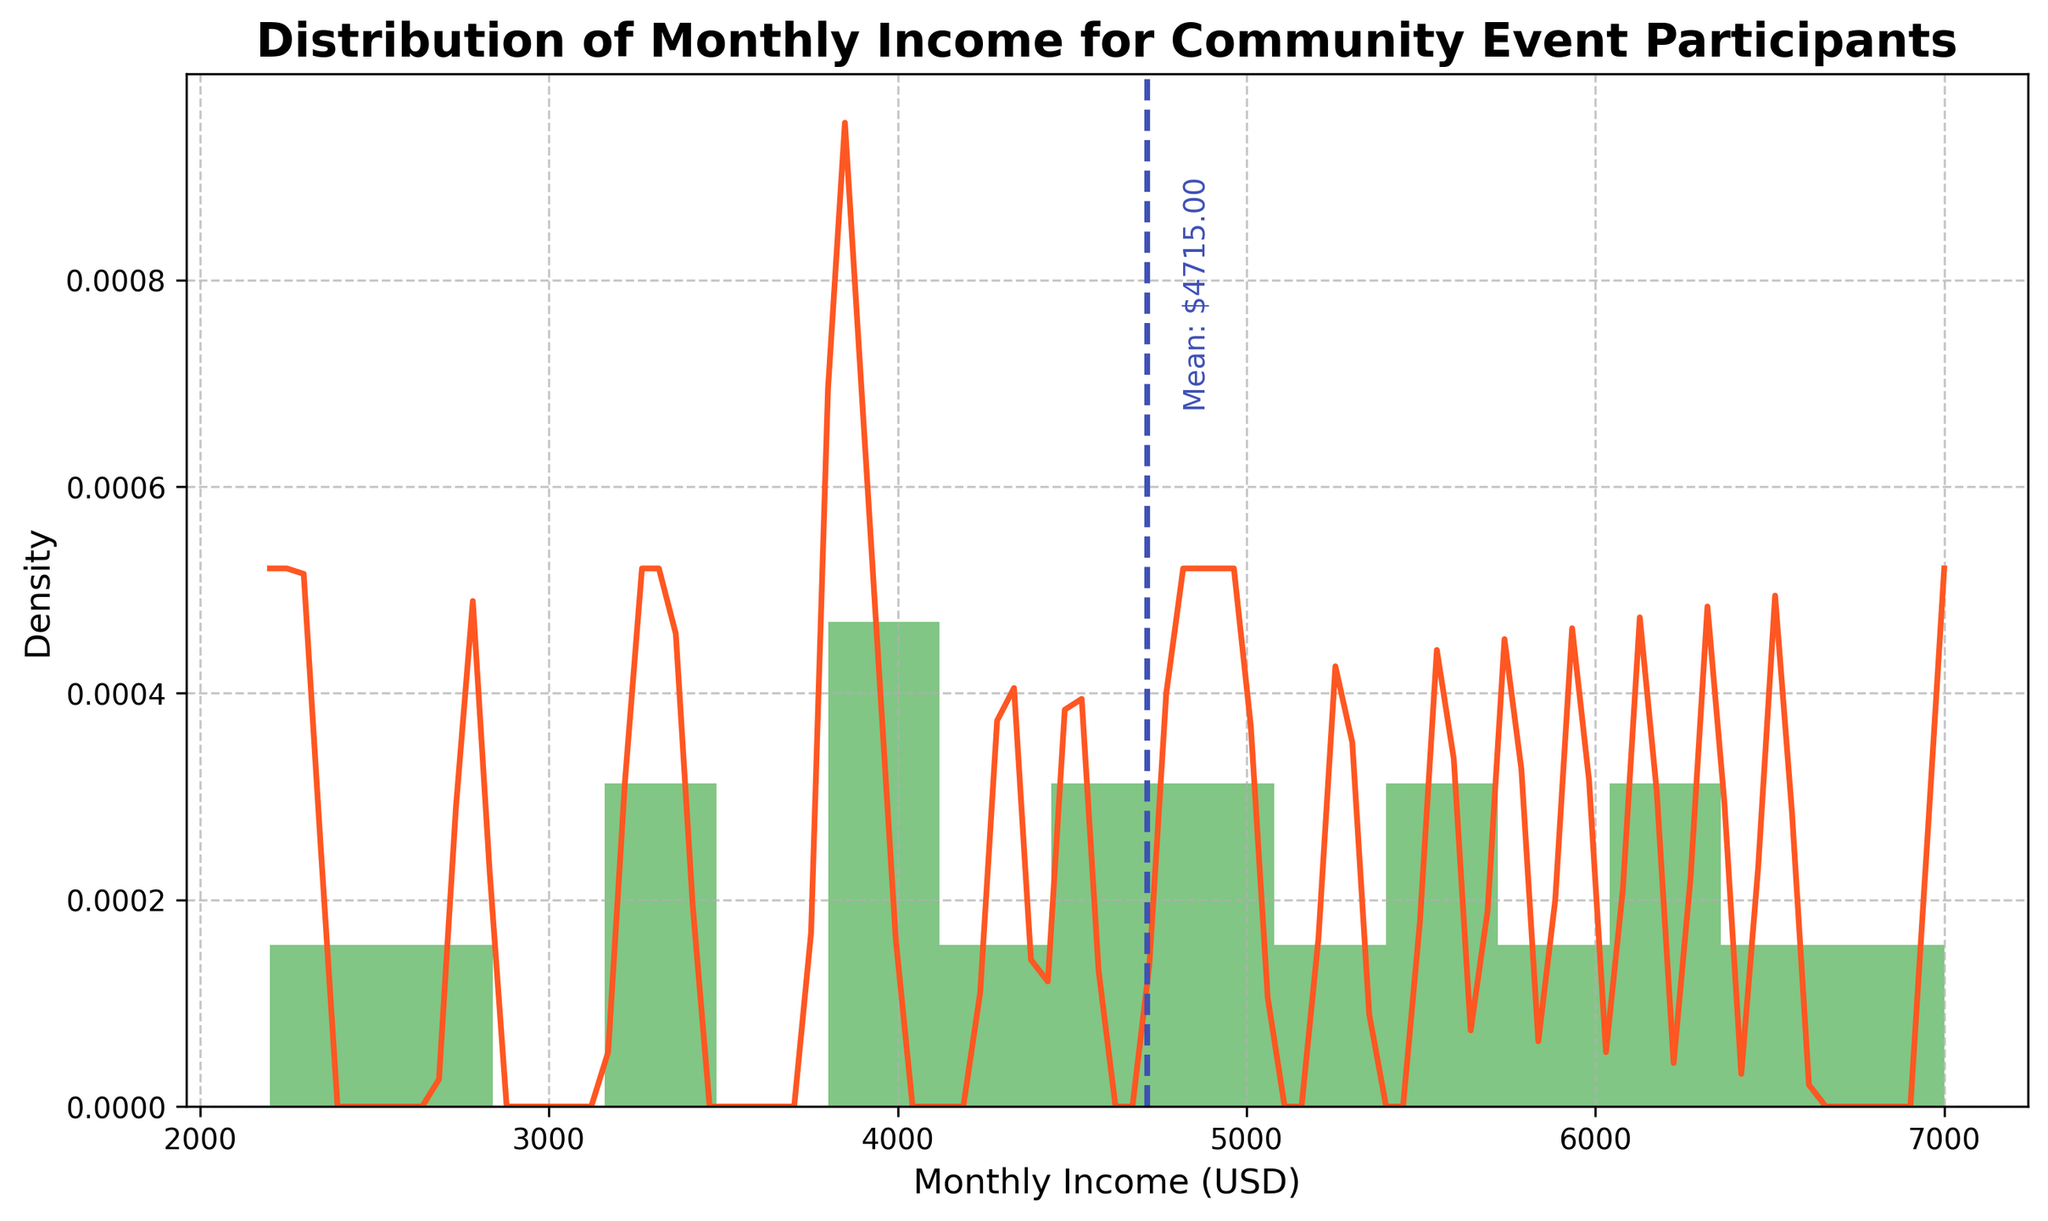What's the title of the figure? The title is usually located at the top of the figure. It indicates the main subject of the plot.
Answer: Distribution of Monthly Income for Community Event Participants What's the mean monthly income of the participants? The plot has a vertical dashed line indicating the mean monthly income, with a text label next to it.
Answer: \$4800.00 Between which two income ranges do most participant incomes fall? The highest bars in the histogram indicate where most data lies. These bars will span specific income ranges on the x-axis.
Answer: \$3500 to \$5000 How many density peaks does the plot show? The peaks can be seen as high points in the density curve (KDE) plotted over the histogram.
Answer: 1 Which color represents the density curve? The density curve is plotted with a specific color, different from the histogram. By visually identifying the curve's color, we can answer this.
Answer: Orange What is the range of the x-axis shown in the figure? The x-axis range is given by the minimum and maximum values labeled on the axis.
Answer: \$2000 to \$7000 How does the income distribution appear based on the plot? This involves assessing the overall shape of the histogram and the density curve to describe the distribution. Look for characteristics like symmetry, skewness, or number of modes.
Answer: Right-skewed What is the approximate income level where the density curve reaches its maximum height? Identify the highest point on the density curve and read the corresponding x-axis value.
Answer: Around \$4500 How does the mean monthly income compare to the median monthly income? To estimate the median, we look for a point where the areas under the density curve are approximately equal on both sides. Compare the mean line to this point.
Answer: Mean is slightly higher What is the density at the mean income level? Locate the mean income on the x-axis, then find the corresponding height of the density curve at this point.
Answer: Around 0.0003 